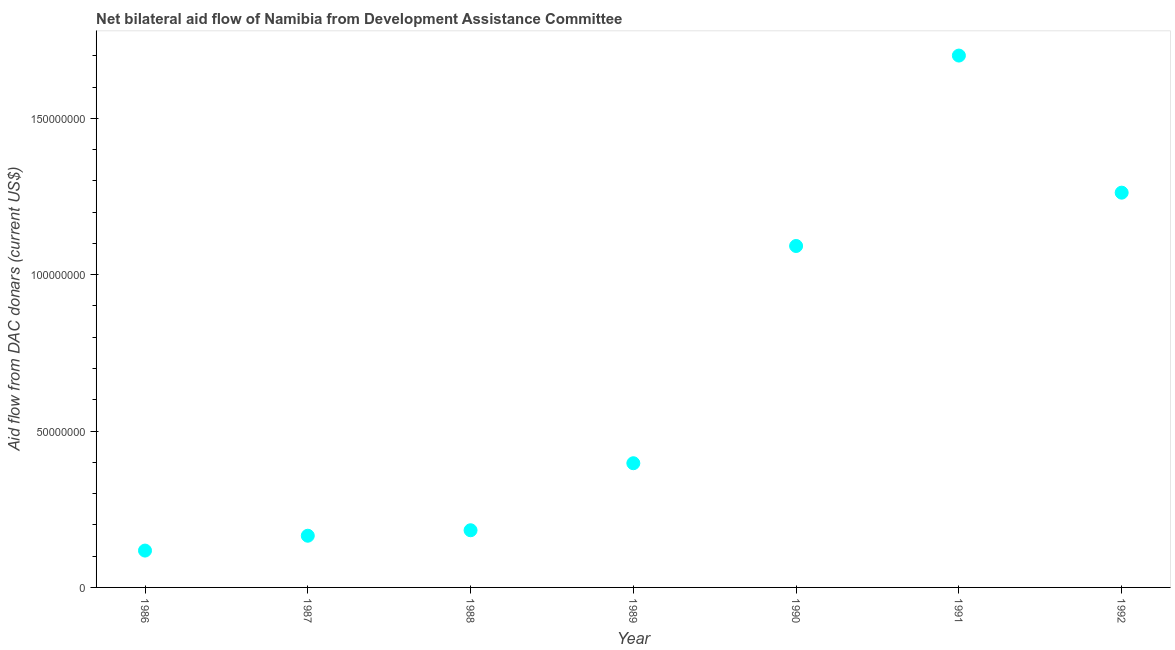What is the net bilateral aid flows from dac donors in 1990?
Your answer should be compact. 1.09e+08. Across all years, what is the maximum net bilateral aid flows from dac donors?
Provide a short and direct response. 1.70e+08. Across all years, what is the minimum net bilateral aid flows from dac donors?
Your answer should be compact. 1.18e+07. In which year was the net bilateral aid flows from dac donors minimum?
Ensure brevity in your answer.  1986. What is the sum of the net bilateral aid flows from dac donors?
Provide a succinct answer. 4.92e+08. What is the difference between the net bilateral aid flows from dac donors in 1987 and 1991?
Your response must be concise. -1.54e+08. What is the average net bilateral aid flows from dac donors per year?
Your answer should be compact. 7.02e+07. What is the median net bilateral aid flows from dac donors?
Give a very brief answer. 3.97e+07. In how many years, is the net bilateral aid flows from dac donors greater than 140000000 US$?
Give a very brief answer. 1. What is the ratio of the net bilateral aid flows from dac donors in 1989 to that in 1990?
Offer a terse response. 0.36. Is the net bilateral aid flows from dac donors in 1987 less than that in 1989?
Ensure brevity in your answer.  Yes. Is the difference between the net bilateral aid flows from dac donors in 1991 and 1992 greater than the difference between any two years?
Provide a short and direct response. No. What is the difference between the highest and the second highest net bilateral aid flows from dac donors?
Offer a terse response. 4.38e+07. Is the sum of the net bilateral aid flows from dac donors in 1990 and 1991 greater than the maximum net bilateral aid flows from dac donors across all years?
Give a very brief answer. Yes. What is the difference between the highest and the lowest net bilateral aid flows from dac donors?
Provide a short and direct response. 1.58e+08. In how many years, is the net bilateral aid flows from dac donors greater than the average net bilateral aid flows from dac donors taken over all years?
Give a very brief answer. 3. Does the net bilateral aid flows from dac donors monotonically increase over the years?
Your answer should be very brief. No. How many dotlines are there?
Your answer should be compact. 1. How many years are there in the graph?
Provide a short and direct response. 7. What is the difference between two consecutive major ticks on the Y-axis?
Make the answer very short. 5.00e+07. Does the graph contain any zero values?
Keep it short and to the point. No. Does the graph contain grids?
Offer a very short reply. No. What is the title of the graph?
Your answer should be compact. Net bilateral aid flow of Namibia from Development Assistance Committee. What is the label or title of the Y-axis?
Offer a terse response. Aid flow from DAC donars (current US$). What is the Aid flow from DAC donars (current US$) in 1986?
Your answer should be very brief. 1.18e+07. What is the Aid flow from DAC donars (current US$) in 1987?
Offer a very short reply. 1.65e+07. What is the Aid flow from DAC donars (current US$) in 1988?
Your answer should be very brief. 1.83e+07. What is the Aid flow from DAC donars (current US$) in 1989?
Give a very brief answer. 3.97e+07. What is the Aid flow from DAC donars (current US$) in 1990?
Offer a terse response. 1.09e+08. What is the Aid flow from DAC donars (current US$) in 1991?
Give a very brief answer. 1.70e+08. What is the Aid flow from DAC donars (current US$) in 1992?
Provide a succinct answer. 1.26e+08. What is the difference between the Aid flow from DAC donars (current US$) in 1986 and 1987?
Provide a succinct answer. -4.75e+06. What is the difference between the Aid flow from DAC donars (current US$) in 1986 and 1988?
Provide a short and direct response. -6.50e+06. What is the difference between the Aid flow from DAC donars (current US$) in 1986 and 1989?
Make the answer very short. -2.79e+07. What is the difference between the Aid flow from DAC donars (current US$) in 1986 and 1990?
Keep it short and to the point. -9.74e+07. What is the difference between the Aid flow from DAC donars (current US$) in 1986 and 1991?
Offer a very short reply. -1.58e+08. What is the difference between the Aid flow from DAC donars (current US$) in 1986 and 1992?
Your answer should be very brief. -1.14e+08. What is the difference between the Aid flow from DAC donars (current US$) in 1987 and 1988?
Make the answer very short. -1.75e+06. What is the difference between the Aid flow from DAC donars (current US$) in 1987 and 1989?
Ensure brevity in your answer.  -2.32e+07. What is the difference between the Aid flow from DAC donars (current US$) in 1987 and 1990?
Ensure brevity in your answer.  -9.26e+07. What is the difference between the Aid flow from DAC donars (current US$) in 1987 and 1991?
Provide a short and direct response. -1.54e+08. What is the difference between the Aid flow from DAC donars (current US$) in 1987 and 1992?
Provide a short and direct response. -1.10e+08. What is the difference between the Aid flow from DAC donars (current US$) in 1988 and 1989?
Ensure brevity in your answer.  -2.14e+07. What is the difference between the Aid flow from DAC donars (current US$) in 1988 and 1990?
Ensure brevity in your answer.  -9.09e+07. What is the difference between the Aid flow from DAC donars (current US$) in 1988 and 1991?
Your response must be concise. -1.52e+08. What is the difference between the Aid flow from DAC donars (current US$) in 1988 and 1992?
Provide a short and direct response. -1.08e+08. What is the difference between the Aid flow from DAC donars (current US$) in 1989 and 1990?
Keep it short and to the point. -6.95e+07. What is the difference between the Aid flow from DAC donars (current US$) in 1989 and 1991?
Your answer should be very brief. -1.30e+08. What is the difference between the Aid flow from DAC donars (current US$) in 1989 and 1992?
Your response must be concise. -8.65e+07. What is the difference between the Aid flow from DAC donars (current US$) in 1990 and 1991?
Provide a succinct answer. -6.09e+07. What is the difference between the Aid flow from DAC donars (current US$) in 1990 and 1992?
Your answer should be compact. -1.70e+07. What is the difference between the Aid flow from DAC donars (current US$) in 1991 and 1992?
Ensure brevity in your answer.  4.38e+07. What is the ratio of the Aid flow from DAC donars (current US$) in 1986 to that in 1987?
Make the answer very short. 0.71. What is the ratio of the Aid flow from DAC donars (current US$) in 1986 to that in 1988?
Make the answer very short. 0.64. What is the ratio of the Aid flow from DAC donars (current US$) in 1986 to that in 1989?
Offer a terse response. 0.3. What is the ratio of the Aid flow from DAC donars (current US$) in 1986 to that in 1990?
Your response must be concise. 0.11. What is the ratio of the Aid flow from DAC donars (current US$) in 1986 to that in 1991?
Provide a short and direct response. 0.07. What is the ratio of the Aid flow from DAC donars (current US$) in 1986 to that in 1992?
Make the answer very short. 0.09. What is the ratio of the Aid flow from DAC donars (current US$) in 1987 to that in 1988?
Give a very brief answer. 0.9. What is the ratio of the Aid flow from DAC donars (current US$) in 1987 to that in 1989?
Your answer should be compact. 0.42. What is the ratio of the Aid flow from DAC donars (current US$) in 1987 to that in 1990?
Your answer should be compact. 0.15. What is the ratio of the Aid flow from DAC donars (current US$) in 1987 to that in 1991?
Offer a very short reply. 0.1. What is the ratio of the Aid flow from DAC donars (current US$) in 1987 to that in 1992?
Keep it short and to the point. 0.13. What is the ratio of the Aid flow from DAC donars (current US$) in 1988 to that in 1989?
Offer a very short reply. 0.46. What is the ratio of the Aid flow from DAC donars (current US$) in 1988 to that in 1990?
Provide a short and direct response. 0.17. What is the ratio of the Aid flow from DAC donars (current US$) in 1988 to that in 1991?
Provide a succinct answer. 0.11. What is the ratio of the Aid flow from DAC donars (current US$) in 1988 to that in 1992?
Offer a very short reply. 0.14. What is the ratio of the Aid flow from DAC donars (current US$) in 1989 to that in 1990?
Offer a terse response. 0.36. What is the ratio of the Aid flow from DAC donars (current US$) in 1989 to that in 1991?
Your answer should be very brief. 0.23. What is the ratio of the Aid flow from DAC donars (current US$) in 1989 to that in 1992?
Your answer should be very brief. 0.32. What is the ratio of the Aid flow from DAC donars (current US$) in 1990 to that in 1991?
Your response must be concise. 0.64. What is the ratio of the Aid flow from DAC donars (current US$) in 1990 to that in 1992?
Make the answer very short. 0.86. What is the ratio of the Aid flow from DAC donars (current US$) in 1991 to that in 1992?
Your answer should be very brief. 1.35. 